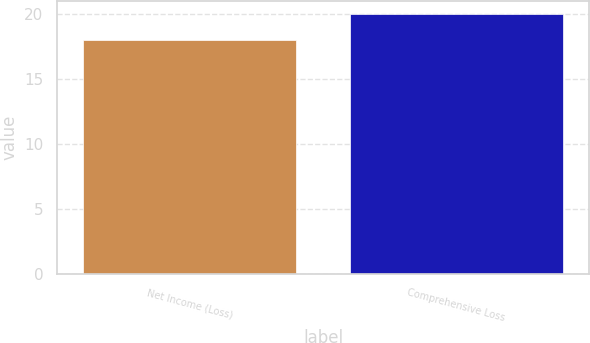Convert chart to OTSL. <chart><loc_0><loc_0><loc_500><loc_500><bar_chart><fcel>Net Income (Loss)<fcel>Comprehensive Loss<nl><fcel>18<fcel>20<nl></chart> 